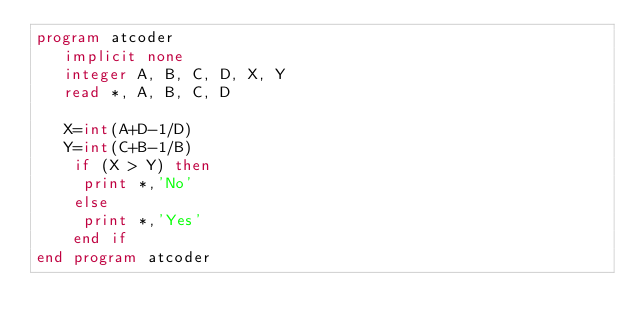<code> <loc_0><loc_0><loc_500><loc_500><_FORTRAN_>program atcoder
   implicit none
   integer A, B, C, D, X, Y
   read *, A, B, C, D
   
   X=int(A+D-1/D)
   Y=int(C+B-1/B)
    if (X > Y) then
     print *,'No'
    else
     print *,'Yes'
    end if
end program atcoder</code> 